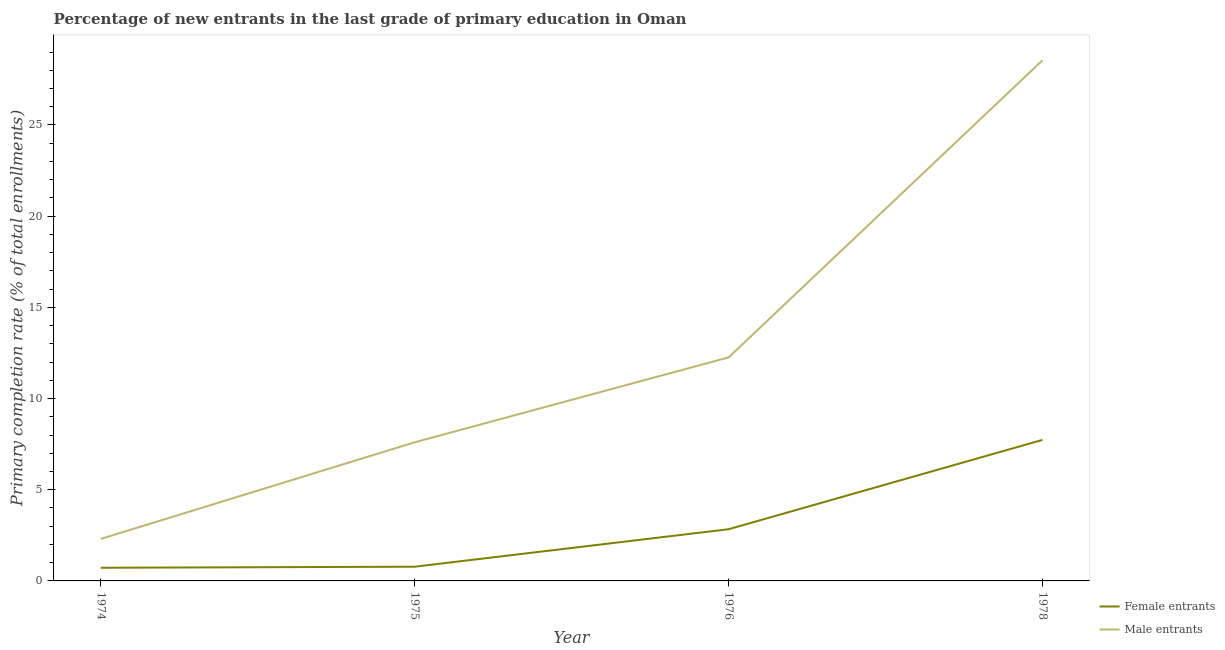Is the number of lines equal to the number of legend labels?
Make the answer very short. Yes. What is the primary completion rate of male entrants in 1975?
Keep it short and to the point. 7.6. Across all years, what is the maximum primary completion rate of female entrants?
Give a very brief answer. 7.73. Across all years, what is the minimum primary completion rate of female entrants?
Make the answer very short. 0.72. In which year was the primary completion rate of male entrants maximum?
Offer a terse response. 1978. In which year was the primary completion rate of male entrants minimum?
Offer a terse response. 1974. What is the total primary completion rate of male entrants in the graph?
Make the answer very short. 50.71. What is the difference between the primary completion rate of female entrants in 1975 and that in 1976?
Give a very brief answer. -2.05. What is the difference between the primary completion rate of male entrants in 1978 and the primary completion rate of female entrants in 1975?
Offer a terse response. 27.77. What is the average primary completion rate of female entrants per year?
Make the answer very short. 3.02. In the year 1975, what is the difference between the primary completion rate of male entrants and primary completion rate of female entrants?
Provide a short and direct response. 6.82. What is the ratio of the primary completion rate of female entrants in 1974 to that in 1976?
Your answer should be very brief. 0.25. Is the difference between the primary completion rate of male entrants in 1976 and 1978 greater than the difference between the primary completion rate of female entrants in 1976 and 1978?
Offer a terse response. No. What is the difference between the highest and the second highest primary completion rate of male entrants?
Offer a terse response. 16.29. What is the difference between the highest and the lowest primary completion rate of male entrants?
Offer a very short reply. 26.24. Is the sum of the primary completion rate of female entrants in 1974 and 1975 greater than the maximum primary completion rate of male entrants across all years?
Offer a very short reply. No. Is the primary completion rate of male entrants strictly greater than the primary completion rate of female entrants over the years?
Provide a succinct answer. Yes. Is the primary completion rate of female entrants strictly less than the primary completion rate of male entrants over the years?
Your answer should be very brief. Yes. What is the difference between two consecutive major ticks on the Y-axis?
Your answer should be compact. 5. Does the graph contain any zero values?
Offer a terse response. No. Does the graph contain grids?
Ensure brevity in your answer.  No. How are the legend labels stacked?
Ensure brevity in your answer.  Vertical. What is the title of the graph?
Your answer should be compact. Percentage of new entrants in the last grade of primary education in Oman. What is the label or title of the Y-axis?
Offer a terse response. Primary completion rate (% of total enrollments). What is the Primary completion rate (% of total enrollments) of Female entrants in 1974?
Give a very brief answer. 0.72. What is the Primary completion rate (% of total enrollments) in Male entrants in 1974?
Your answer should be very brief. 2.3. What is the Primary completion rate (% of total enrollments) of Female entrants in 1975?
Your answer should be compact. 0.78. What is the Primary completion rate (% of total enrollments) in Male entrants in 1975?
Keep it short and to the point. 7.6. What is the Primary completion rate (% of total enrollments) of Female entrants in 1976?
Ensure brevity in your answer.  2.83. What is the Primary completion rate (% of total enrollments) of Male entrants in 1976?
Your response must be concise. 12.26. What is the Primary completion rate (% of total enrollments) of Female entrants in 1978?
Ensure brevity in your answer.  7.73. What is the Primary completion rate (% of total enrollments) of Male entrants in 1978?
Provide a short and direct response. 28.55. Across all years, what is the maximum Primary completion rate (% of total enrollments) of Female entrants?
Your answer should be compact. 7.73. Across all years, what is the maximum Primary completion rate (% of total enrollments) in Male entrants?
Provide a short and direct response. 28.55. Across all years, what is the minimum Primary completion rate (% of total enrollments) in Female entrants?
Your answer should be compact. 0.72. Across all years, what is the minimum Primary completion rate (% of total enrollments) in Male entrants?
Offer a very short reply. 2.3. What is the total Primary completion rate (% of total enrollments) of Female entrants in the graph?
Ensure brevity in your answer.  12.07. What is the total Primary completion rate (% of total enrollments) in Male entrants in the graph?
Your answer should be very brief. 50.71. What is the difference between the Primary completion rate (% of total enrollments) in Female entrants in 1974 and that in 1975?
Keep it short and to the point. -0.06. What is the difference between the Primary completion rate (% of total enrollments) of Male entrants in 1974 and that in 1975?
Give a very brief answer. -5.3. What is the difference between the Primary completion rate (% of total enrollments) of Female entrants in 1974 and that in 1976?
Offer a very short reply. -2.11. What is the difference between the Primary completion rate (% of total enrollments) of Male entrants in 1974 and that in 1976?
Your answer should be compact. -9.95. What is the difference between the Primary completion rate (% of total enrollments) in Female entrants in 1974 and that in 1978?
Make the answer very short. -7.01. What is the difference between the Primary completion rate (% of total enrollments) in Male entrants in 1974 and that in 1978?
Make the answer very short. -26.24. What is the difference between the Primary completion rate (% of total enrollments) of Female entrants in 1975 and that in 1976?
Make the answer very short. -2.05. What is the difference between the Primary completion rate (% of total enrollments) of Male entrants in 1975 and that in 1976?
Provide a succinct answer. -4.65. What is the difference between the Primary completion rate (% of total enrollments) in Female entrants in 1975 and that in 1978?
Your response must be concise. -6.95. What is the difference between the Primary completion rate (% of total enrollments) of Male entrants in 1975 and that in 1978?
Your answer should be compact. -20.95. What is the difference between the Primary completion rate (% of total enrollments) of Female entrants in 1976 and that in 1978?
Your response must be concise. -4.9. What is the difference between the Primary completion rate (% of total enrollments) in Male entrants in 1976 and that in 1978?
Provide a short and direct response. -16.29. What is the difference between the Primary completion rate (% of total enrollments) of Female entrants in 1974 and the Primary completion rate (% of total enrollments) of Male entrants in 1975?
Keep it short and to the point. -6.88. What is the difference between the Primary completion rate (% of total enrollments) in Female entrants in 1974 and the Primary completion rate (% of total enrollments) in Male entrants in 1976?
Make the answer very short. -11.53. What is the difference between the Primary completion rate (% of total enrollments) in Female entrants in 1974 and the Primary completion rate (% of total enrollments) in Male entrants in 1978?
Your answer should be very brief. -27.83. What is the difference between the Primary completion rate (% of total enrollments) in Female entrants in 1975 and the Primary completion rate (% of total enrollments) in Male entrants in 1976?
Give a very brief answer. -11.48. What is the difference between the Primary completion rate (% of total enrollments) of Female entrants in 1975 and the Primary completion rate (% of total enrollments) of Male entrants in 1978?
Ensure brevity in your answer.  -27.77. What is the difference between the Primary completion rate (% of total enrollments) in Female entrants in 1976 and the Primary completion rate (% of total enrollments) in Male entrants in 1978?
Offer a terse response. -25.71. What is the average Primary completion rate (% of total enrollments) of Female entrants per year?
Your answer should be compact. 3.02. What is the average Primary completion rate (% of total enrollments) in Male entrants per year?
Offer a terse response. 12.68. In the year 1974, what is the difference between the Primary completion rate (% of total enrollments) in Female entrants and Primary completion rate (% of total enrollments) in Male entrants?
Give a very brief answer. -1.58. In the year 1975, what is the difference between the Primary completion rate (% of total enrollments) of Female entrants and Primary completion rate (% of total enrollments) of Male entrants?
Offer a terse response. -6.82. In the year 1976, what is the difference between the Primary completion rate (% of total enrollments) of Female entrants and Primary completion rate (% of total enrollments) of Male entrants?
Your answer should be compact. -9.42. In the year 1978, what is the difference between the Primary completion rate (% of total enrollments) in Female entrants and Primary completion rate (% of total enrollments) in Male entrants?
Provide a short and direct response. -20.81. What is the ratio of the Primary completion rate (% of total enrollments) in Female entrants in 1974 to that in 1975?
Your answer should be very brief. 0.92. What is the ratio of the Primary completion rate (% of total enrollments) of Male entrants in 1974 to that in 1975?
Your response must be concise. 0.3. What is the ratio of the Primary completion rate (% of total enrollments) of Female entrants in 1974 to that in 1976?
Make the answer very short. 0.25. What is the ratio of the Primary completion rate (% of total enrollments) in Male entrants in 1974 to that in 1976?
Provide a short and direct response. 0.19. What is the ratio of the Primary completion rate (% of total enrollments) in Female entrants in 1974 to that in 1978?
Your response must be concise. 0.09. What is the ratio of the Primary completion rate (% of total enrollments) of Male entrants in 1974 to that in 1978?
Give a very brief answer. 0.08. What is the ratio of the Primary completion rate (% of total enrollments) of Female entrants in 1975 to that in 1976?
Make the answer very short. 0.28. What is the ratio of the Primary completion rate (% of total enrollments) in Male entrants in 1975 to that in 1976?
Make the answer very short. 0.62. What is the ratio of the Primary completion rate (% of total enrollments) in Female entrants in 1975 to that in 1978?
Give a very brief answer. 0.1. What is the ratio of the Primary completion rate (% of total enrollments) in Male entrants in 1975 to that in 1978?
Your answer should be very brief. 0.27. What is the ratio of the Primary completion rate (% of total enrollments) in Female entrants in 1976 to that in 1978?
Keep it short and to the point. 0.37. What is the ratio of the Primary completion rate (% of total enrollments) of Male entrants in 1976 to that in 1978?
Keep it short and to the point. 0.43. What is the difference between the highest and the second highest Primary completion rate (% of total enrollments) of Female entrants?
Your response must be concise. 4.9. What is the difference between the highest and the second highest Primary completion rate (% of total enrollments) in Male entrants?
Offer a terse response. 16.29. What is the difference between the highest and the lowest Primary completion rate (% of total enrollments) in Female entrants?
Provide a short and direct response. 7.01. What is the difference between the highest and the lowest Primary completion rate (% of total enrollments) in Male entrants?
Your answer should be compact. 26.24. 